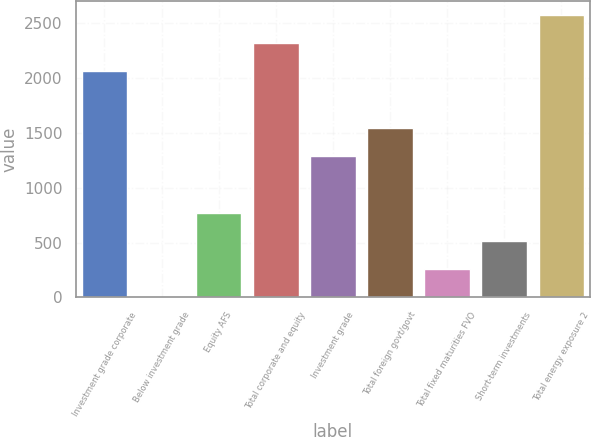Convert chart. <chart><loc_0><loc_0><loc_500><loc_500><bar_chart><fcel>Investment grade corporate<fcel>Below investment grade<fcel>Equity AFS<fcel>Total corporate and equity<fcel>Investment grade<fcel>Total foreign govt/govt<fcel>Total fixed maturities FVO<fcel>Short-term investments<fcel>Total energy exposure 2<nl><fcel>2058<fcel>6<fcel>772.8<fcel>2313.6<fcel>1284<fcel>1539.6<fcel>261.6<fcel>517.2<fcel>2569.2<nl></chart> 